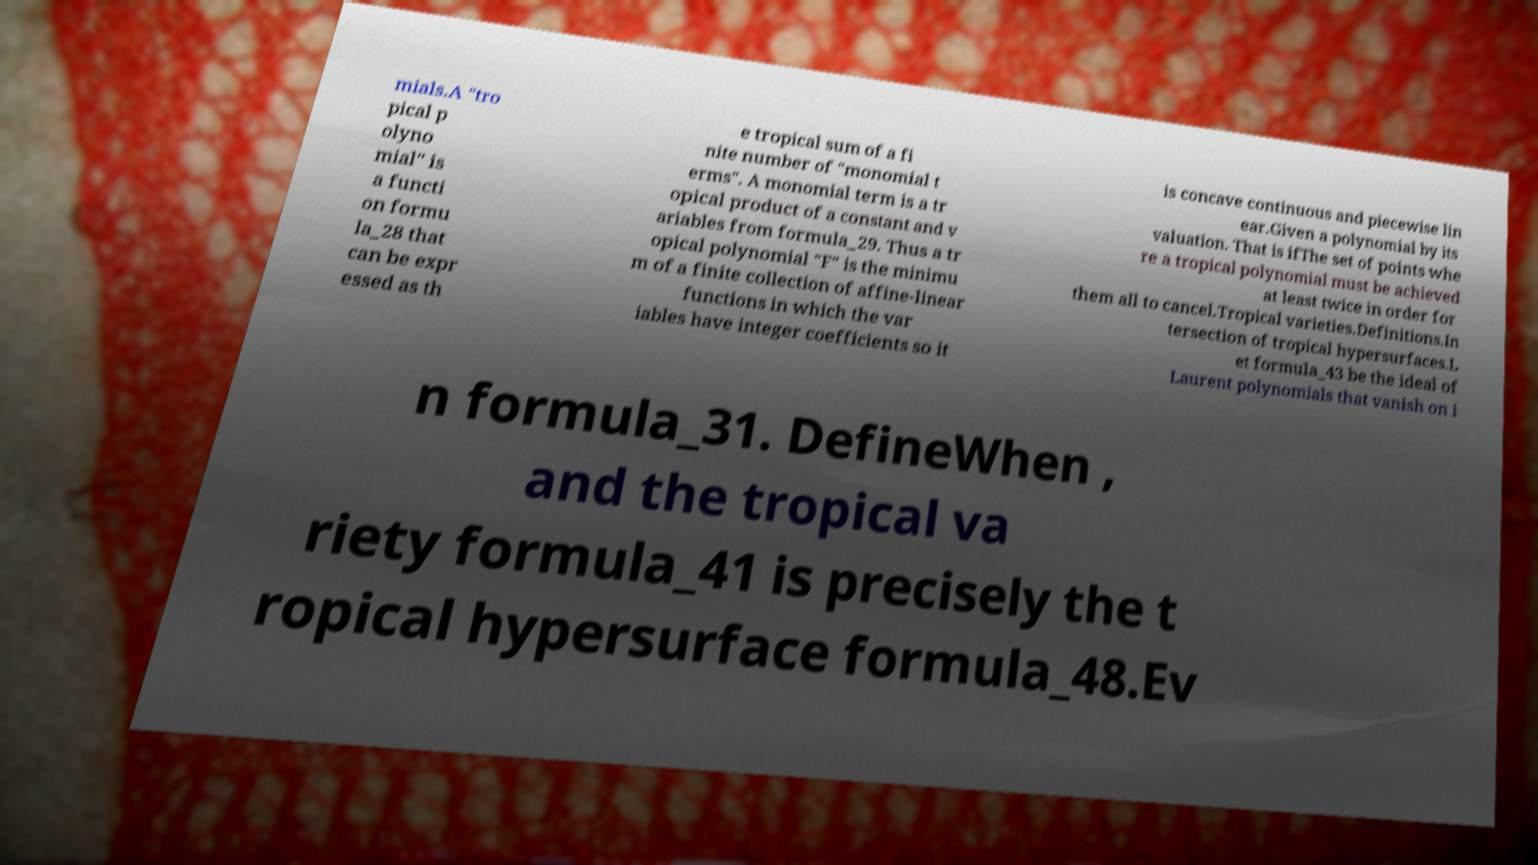I need the written content from this picture converted into text. Can you do that? mials.A "tro pical p olyno mial" is a functi on formu la_28 that can be expr essed as th e tropical sum of a fi nite number of "monomial t erms". A monomial term is a tr opical product of a constant and v ariables from formula_29. Thus a tr opical polynomial "F" is the minimu m of a finite collection of affine-linear functions in which the var iables have integer coefficients so it is concave continuous and piecewise lin ear.Given a polynomial by its valuation. That is ifThe set of points whe re a tropical polynomial must be achieved at least twice in order for them all to cancel.Tropical varieties.Definitions.In tersection of tropical hypersurfaces.L et formula_43 be the ideal of Laurent polynomials that vanish on i n formula_31. DefineWhen , and the tropical va riety formula_41 is precisely the t ropical hypersurface formula_48.Ev 